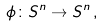Convert formula to latex. <formula><loc_0><loc_0><loc_500><loc_500>\phi \colon S ^ { n } \rightarrow S ^ { n } \, ,</formula> 